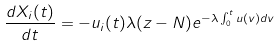Convert formula to latex. <formula><loc_0><loc_0><loc_500><loc_500>\frac { d X _ { i } ( t ) } { d t } = - u _ { i } ( t ) \lambda ( z - N ) e ^ { - \lambda \int _ { 0 } ^ { t } u ( v ) d v }</formula> 